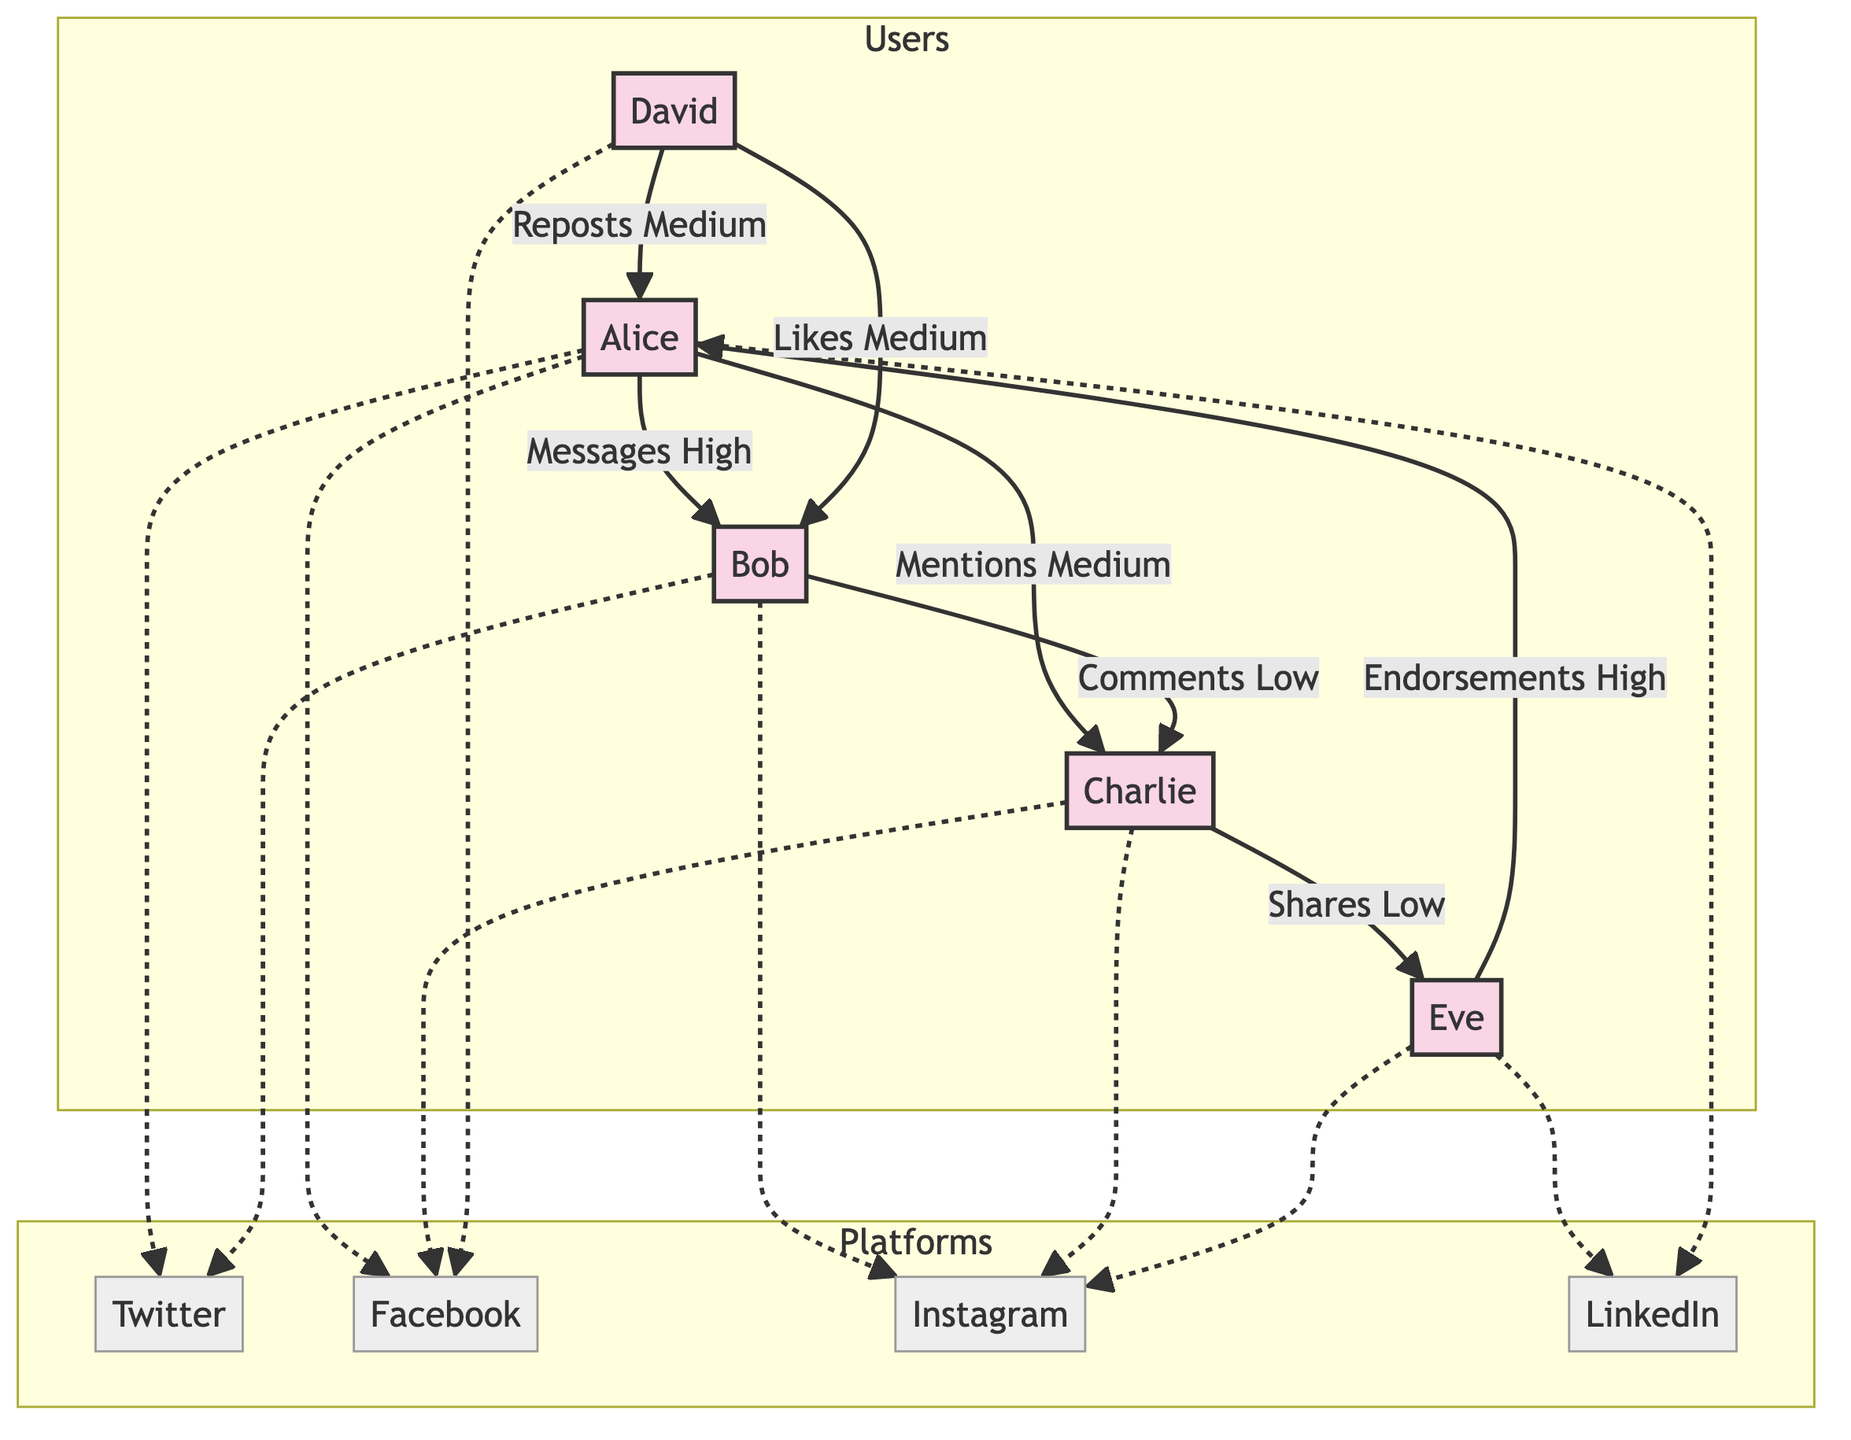What is the interaction type between Alice and Bob? According to the diagram, the directed edge from User1 (Alice) to User2 (Bob) is labeled as "Messages High." This indicates that the interaction type between these two users is through messages, and the frequency of that interaction is high.
Answer: Messages High How many users are in the diagram? In the "Users" subgraph of the diagram, there are five distinct nodes representing users: Alice, Bob, Charlie, David, and Eve. Therefore, the total number of users in the diagram is five.
Answer: 5 Which platform is connected to Charlie? The diagram shows two edges from User3 (Charlie) to the platforms: one dotted line to Platform2 (Facebook) and another dotted line to Platform3 (Instagram). Thus, Charlie is connected to both Facebook and Instagram.
Answer: Facebook and Instagram What type of interaction does David have with Bob? The diagram highlights an edge from User4 (David) to User2 (Bob) labeled "Likes Medium." This indicates that David's interaction with Bob is through likes, with a medium frequency level.
Answer: Likes Medium How many interactions are labeled as 'High' in the diagram? By examining the edges defined in the diagram, there are two interactions that are labeled as 'High': one from Alice to Bob (Messages High) and another from Eve to Alice (Endorsements High). Therefore, there are two interactions labeled as 'High'.
Answer: 2 Who has the largest number of interactions with other users in the diagram? Analyzing the edges, Alice (User1) has three connections: Messages High to Bob, Mentions Medium to Charlie, and Reposts Medium from David. Bob (User2) has two connections, Charlie (User3) has two connections, David (User4) has one connection, and Eve (User5) has one connection. Therefore, the user with the largest number of interactions is Alice.
Answer: Alice What is the interaction strength between Eve and Alice? The diagram shows an edge leading from User5 (Eve) to User1 (Alice) marked as "Endorsements High." Therefore, the interaction strength between Eve and Alice is classified as high.
Answer: Endorsements High How many users interact with Facebook according to the diagram? The diagram presents multiple users connected to Platform2 (Facebook) via dotted lines. Users connected to Facebook are Alice, Charlie, and David, which totals to three users interacting with Facebook.
Answer: 3 What is the relationship between Charlie and Eve? In the diagram, there is a directed edge pointing from User3 (Charlie) to User5 (Eve) labeled "Shares Low." This establishes that Charlie’s relationship with Eve revolves around sharing, and the frequency of that interaction is low.
Answer: Shares Low 